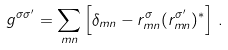<formula> <loc_0><loc_0><loc_500><loc_500>g ^ { \sigma \sigma ^ { \prime } } = \sum _ { m n } \left [ \delta _ { m n } - r _ { m n } ^ { \sigma } ( r _ { m n } ^ { \sigma ^ { \prime } } ) ^ { \ast } \right ] \, .</formula> 